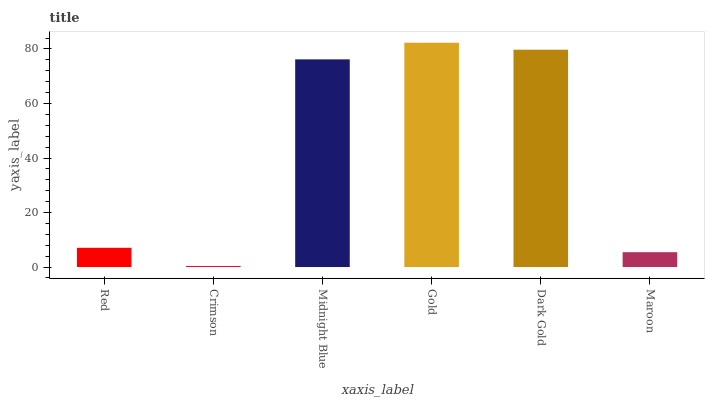Is Midnight Blue the minimum?
Answer yes or no. No. Is Midnight Blue the maximum?
Answer yes or no. No. Is Midnight Blue greater than Crimson?
Answer yes or no. Yes. Is Crimson less than Midnight Blue?
Answer yes or no. Yes. Is Crimson greater than Midnight Blue?
Answer yes or no. No. Is Midnight Blue less than Crimson?
Answer yes or no. No. Is Midnight Blue the high median?
Answer yes or no. Yes. Is Red the low median?
Answer yes or no. Yes. Is Red the high median?
Answer yes or no. No. Is Maroon the low median?
Answer yes or no. No. 